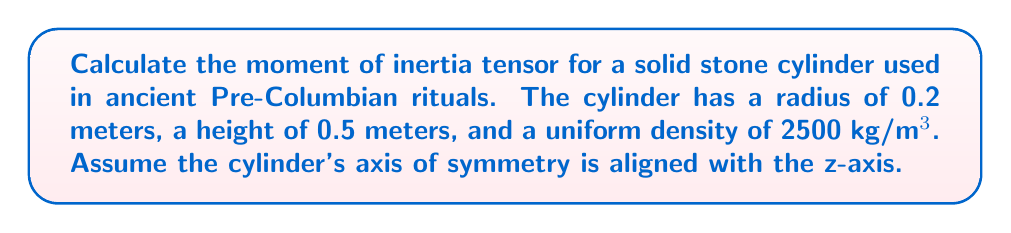Teach me how to tackle this problem. Let's approach this step-by-step:

1) The moment of inertia tensor for a cylinder about its center of mass is diagonal due to its symmetry. It has the form:

   $$I = \begin{pmatrix}
   I_{xx} & 0 & 0 \\
   0 & I_{yy} & 0 \\
   0 & 0 & I_{zz}
   \end{pmatrix}$$

2) For a solid cylinder with radius $r$ and height $h$, the moments of inertia are:

   $$I_{xx} = I_{yy} = \frac{1}{12}m(3r^2 + h^2)$$
   $$I_{zz} = \frac{1}{2}mr^2$$

3) We need to calculate the mass $m$ of the cylinder:
   
   $$m = \rho V = \rho \pi r^2 h$$
   $$m = 2500 \cdot \pi \cdot 0.2^2 \cdot 0.5 = 157.08 \text{ kg}$$

4) Now we can calculate $I_{xx}$ and $I_{yy}$:

   $$I_{xx} = I_{yy} = \frac{1}{12} \cdot 157.08 \cdot (3 \cdot 0.2^2 + 0.5^2)$$
   $$= 13.09 \cdot (0.12 + 0.25) = 4.85 \text{ kg·m²}$$

5) And $I_{zz}$:

   $$I_{zz} = \frac{1}{2} \cdot 157.08 \cdot 0.2^2 = 3.14 \text{ kg·m²}$$

6) Therefore, the moment of inertia tensor is:

   $$I = \begin{pmatrix}
   4.85 & 0 & 0 \\
   0 & 4.85 & 0 \\
   0 & 0 & 3.14
   \end{pmatrix} \text{ kg·m²}$$
Answer: $$I = \begin{pmatrix}
4.85 & 0 & 0 \\
0 & 4.85 & 0 \\
0 & 0 & 3.14
\end{pmatrix} \text{ kg·m²}$$ 